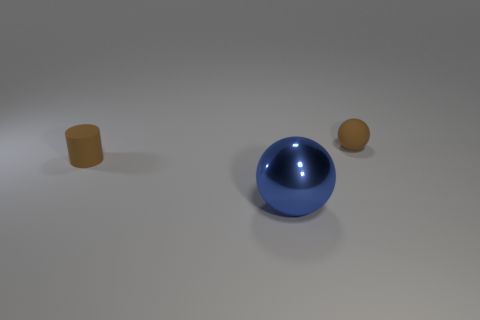Add 2 large cyan rubber cubes. How many objects exist? 5 Subtract all spheres. How many objects are left? 1 Subtract all small things. Subtract all large blue metallic spheres. How many objects are left? 0 Add 1 cylinders. How many cylinders are left? 2 Add 3 gray shiny balls. How many gray shiny balls exist? 3 Subtract 0 blue blocks. How many objects are left? 3 